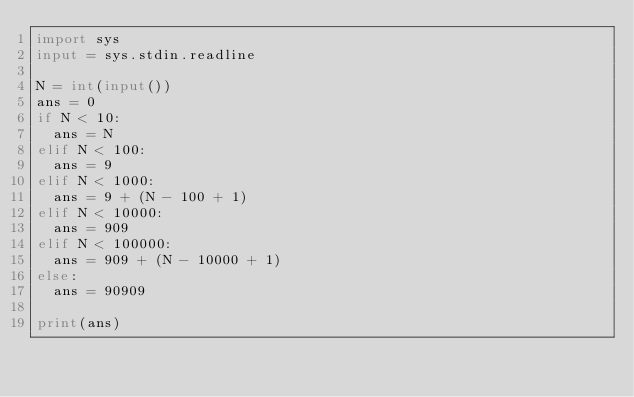Convert code to text. <code><loc_0><loc_0><loc_500><loc_500><_Python_>import sys
input = sys.stdin.readline

N = int(input())
ans = 0
if N < 10:
  ans = N
elif N < 100:
  ans = 9
elif N < 1000:
  ans = 9 + (N - 100 + 1)
elif N < 10000:
  ans = 909
elif N < 100000:
  ans = 909 + (N - 10000 + 1)
else:
  ans = 90909

print(ans)</code> 